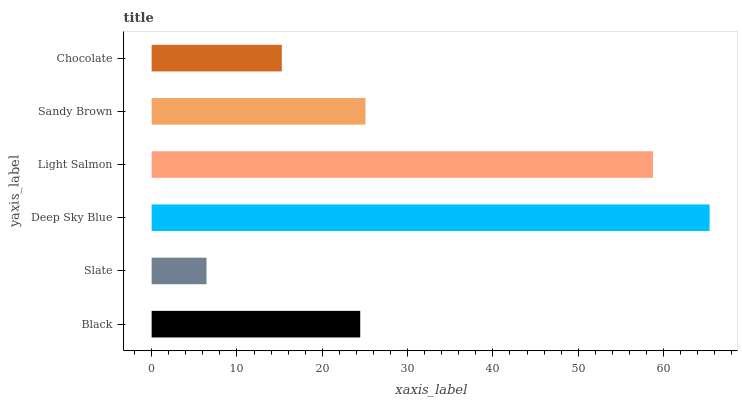Is Slate the minimum?
Answer yes or no. Yes. Is Deep Sky Blue the maximum?
Answer yes or no. Yes. Is Deep Sky Blue the minimum?
Answer yes or no. No. Is Slate the maximum?
Answer yes or no. No. Is Deep Sky Blue greater than Slate?
Answer yes or no. Yes. Is Slate less than Deep Sky Blue?
Answer yes or no. Yes. Is Slate greater than Deep Sky Blue?
Answer yes or no. No. Is Deep Sky Blue less than Slate?
Answer yes or no. No. Is Sandy Brown the high median?
Answer yes or no. Yes. Is Black the low median?
Answer yes or no. Yes. Is Slate the high median?
Answer yes or no. No. Is Deep Sky Blue the low median?
Answer yes or no. No. 